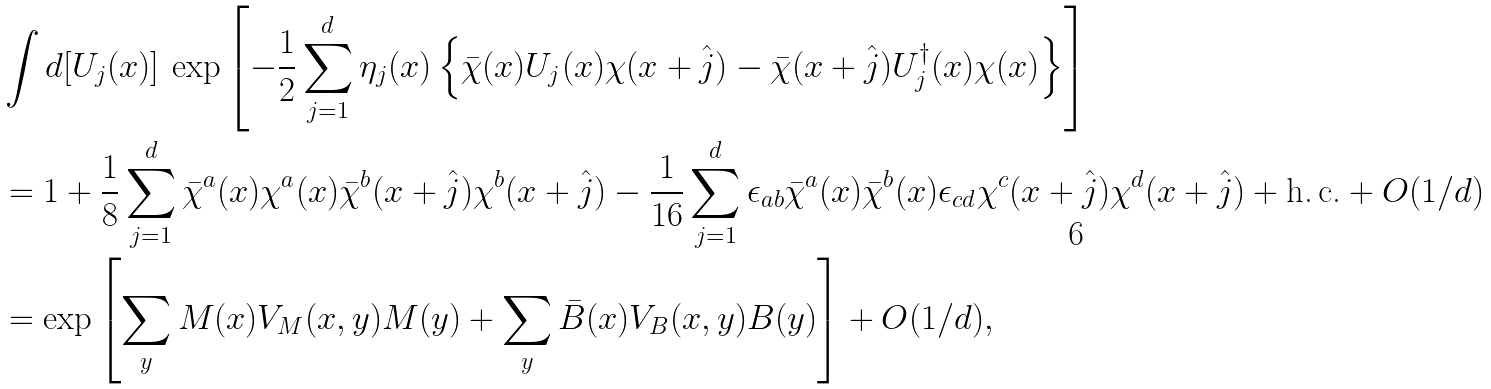Convert formula to latex. <formula><loc_0><loc_0><loc_500><loc_500>& \int d [ U _ { j } ( x ) ] \, \exp \left [ - \frac { 1 } { 2 } \sum _ { j = 1 } ^ { d } \eta _ { j } ( x ) \left \{ \bar { \chi } ( x ) U _ { j } ( x ) \chi ( x + \hat { j } ) - \bar { \chi } ( x + \hat { j } ) U _ { j } ^ { \dagger } ( x ) \chi ( x ) \right \} \right ] \\ & = 1 + \frac { 1 } { 8 } \sum _ { j = 1 } ^ { d } \bar { \chi } ^ { a } ( x ) \chi ^ { a } ( x ) \bar { \chi } ^ { b } ( x + \hat { j } ) \chi ^ { b } ( x + \hat { j } ) - \frac { 1 } { 1 6 } \sum _ { j = 1 } ^ { d } \epsilon _ { a b } \bar { \chi } ^ { a } ( x ) \bar { \chi } ^ { b } ( x ) \epsilon _ { c d } \chi ^ { c } ( x + \hat { j } ) \chi ^ { d } ( x + \hat { j } ) + \text {h.\,c.} + O ( 1 / d ) \\ & = \exp \left [ \sum _ { y } M ( x ) V _ { M } ( x , y ) M ( y ) + \sum _ { y } \bar { B } ( x ) V _ { B } ( x , y ) B ( y ) \right ] + O ( 1 / d ) ,</formula> 